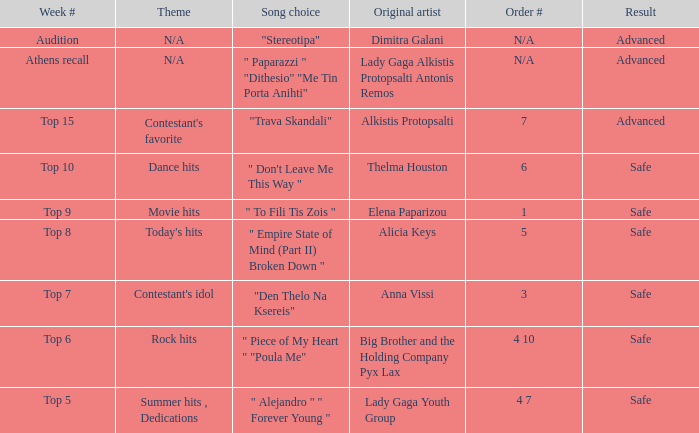Which artists have order number 6? Thelma Houston. 